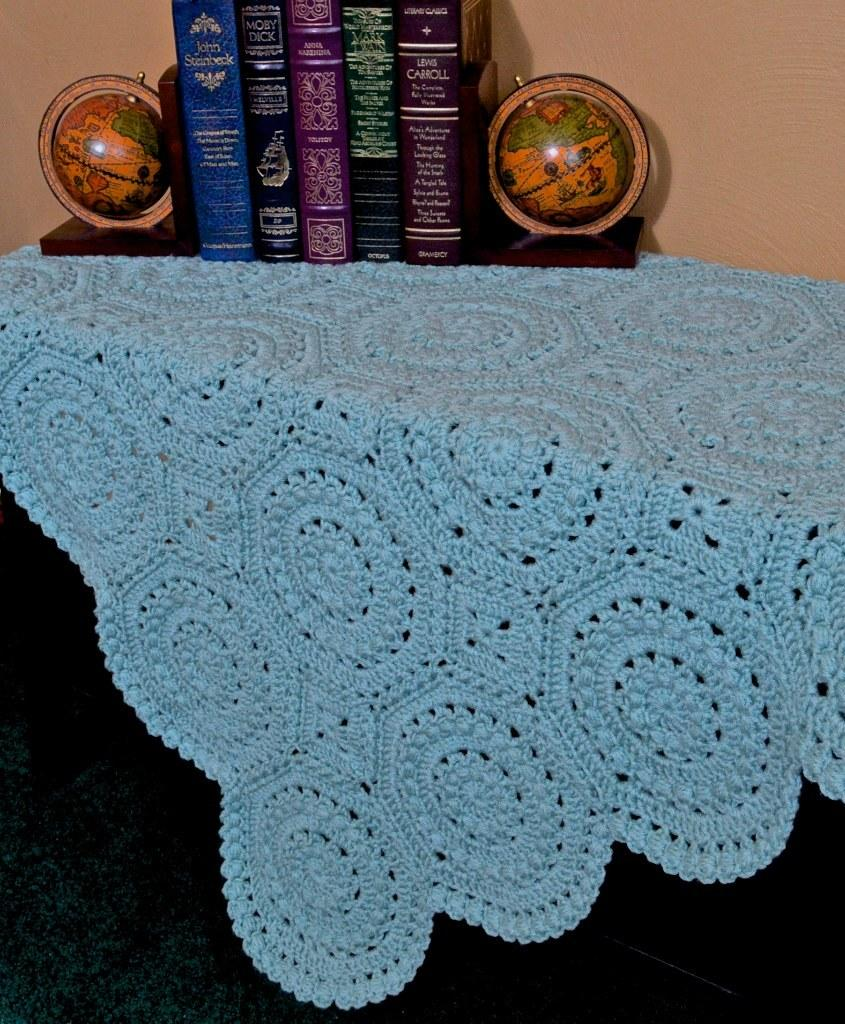<image>
Summarize the visual content of the image. A collection of classic books, including Moby Dick, sits on a table. 